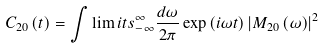<formula> <loc_0><loc_0><loc_500><loc_500>C _ { 2 0 } \left ( t \right ) = \int \lim i t s _ { - \infty } ^ { \infty } { \frac { d \omega } { 2 \pi } \exp \left ( { i \omega t } \right ) \left | { M _ { 2 0 } \left ( \omega \right ) } \right | ^ { 2 } }</formula> 